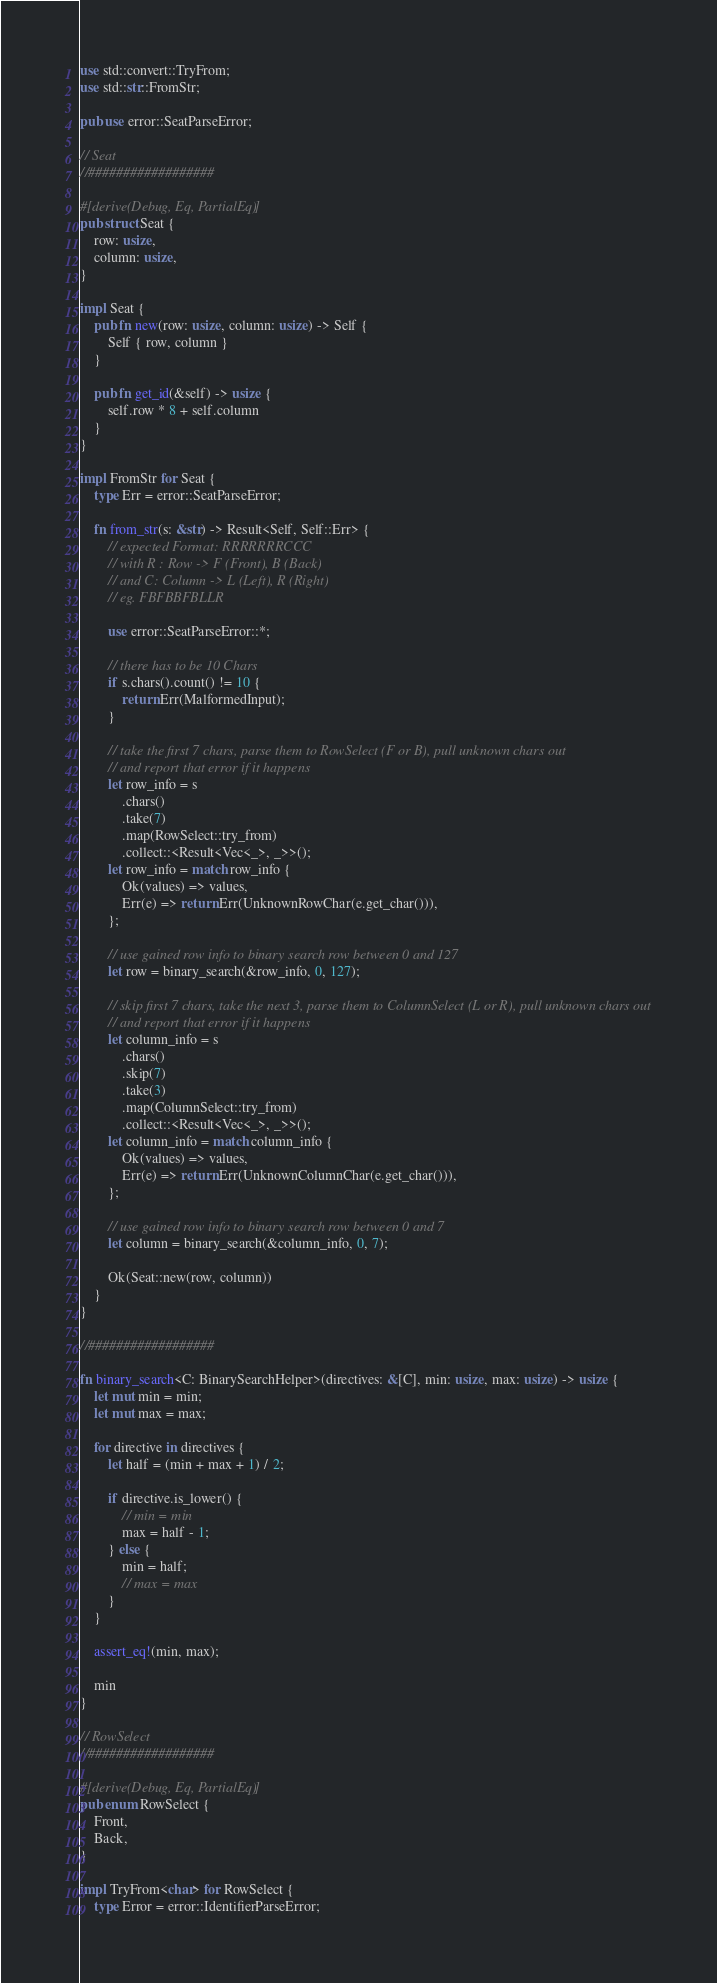Convert code to text. <code><loc_0><loc_0><loc_500><loc_500><_Rust_>use std::convert::TryFrom;
use std::str::FromStr;

pub use error::SeatParseError;

// Seat
//##################

#[derive(Debug, Eq, PartialEq)]
pub struct Seat {
    row: usize,
    column: usize,
}

impl Seat {
    pub fn new(row: usize, column: usize) -> Self {
        Self { row, column }
    }

    pub fn get_id(&self) -> usize {
        self.row * 8 + self.column
    }
}

impl FromStr for Seat {
    type Err = error::SeatParseError;

    fn from_str(s: &str) -> Result<Self, Self::Err> {
        // expected Format: RRRRRRRCCC
        // with R : Row -> F (Front), B (Back)
        // and C: Column -> L (Left), R (Right)
        // eg. FBFBBFBLLR

        use error::SeatParseError::*;

        // there has to be 10 Chars
        if s.chars().count() != 10 {
            return Err(MalformedInput);
        }

        // take the first 7 chars, parse them to RowSelect (F or B), pull unknown chars out
        // and report that error if it happens
        let row_info = s
            .chars()
            .take(7)
            .map(RowSelect::try_from)
            .collect::<Result<Vec<_>, _>>();
        let row_info = match row_info {
            Ok(values) => values,
            Err(e) => return Err(UnknownRowChar(e.get_char())),
        };

        // use gained row info to binary search row between 0 and 127
        let row = binary_search(&row_info, 0, 127);

        // skip first 7 chars, take the next 3, parse them to ColumnSelect (L or R), pull unknown chars out
        // and report that error if it happens
        let column_info = s
            .chars()
            .skip(7)
            .take(3)
            .map(ColumnSelect::try_from)
            .collect::<Result<Vec<_>, _>>();
        let column_info = match column_info {
            Ok(values) => values,
            Err(e) => return Err(UnknownColumnChar(e.get_char())),
        };

        // use gained row info to binary search row between 0 and 7
        let column = binary_search(&column_info, 0, 7);

        Ok(Seat::new(row, column))
    }
}

//##################

fn binary_search<C: BinarySearchHelper>(directives: &[C], min: usize, max: usize) -> usize {
    let mut min = min;
    let mut max = max;

    for directive in directives {
        let half = (min + max + 1) / 2;

        if directive.is_lower() {
            // min = min
            max = half - 1;
        } else {
            min = half;
            // max = max
        }
    }

    assert_eq!(min, max);

    min
}

// RowSelect
//##################

#[derive(Debug, Eq, PartialEq)]
pub enum RowSelect {
    Front,
    Back,
}

impl TryFrom<char> for RowSelect {
    type Error = error::IdentifierParseError;
</code> 